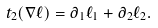<formula> <loc_0><loc_0><loc_500><loc_500>t _ { 2 } ( \nabla \ell ) = \partial _ { 1 } \ell _ { 1 } + \partial _ { 2 } \ell _ { 2 } .</formula> 